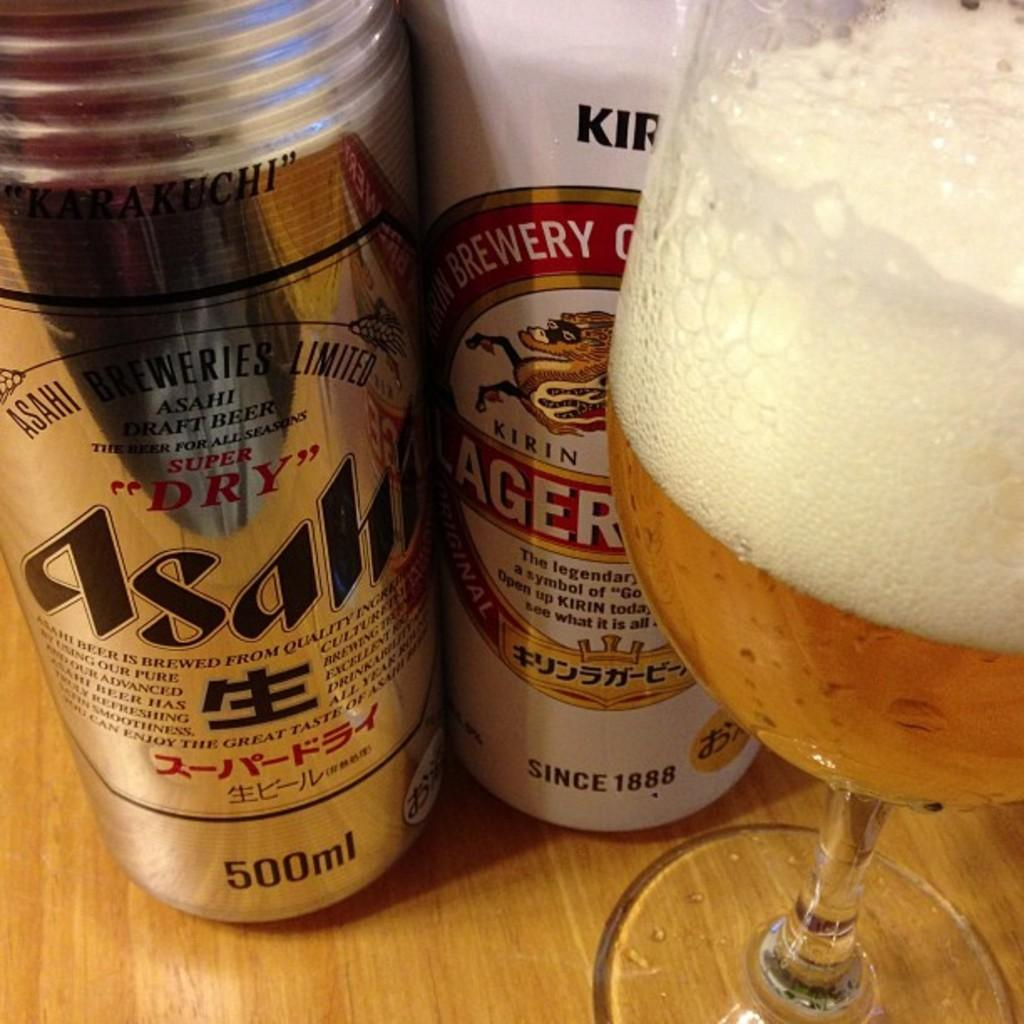<image>
Render a clear and concise summary of the photo. A can of Asahi beer, a can of Kirin Ichiban and a half full glass of beer. 